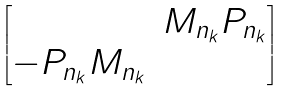Convert formula to latex. <formula><loc_0><loc_0><loc_500><loc_500>\begin{bmatrix} & M _ { n _ { k } } P _ { n _ { k } } \\ - P _ { n _ { k } } M _ { n _ { k } } & \end{bmatrix}</formula> 